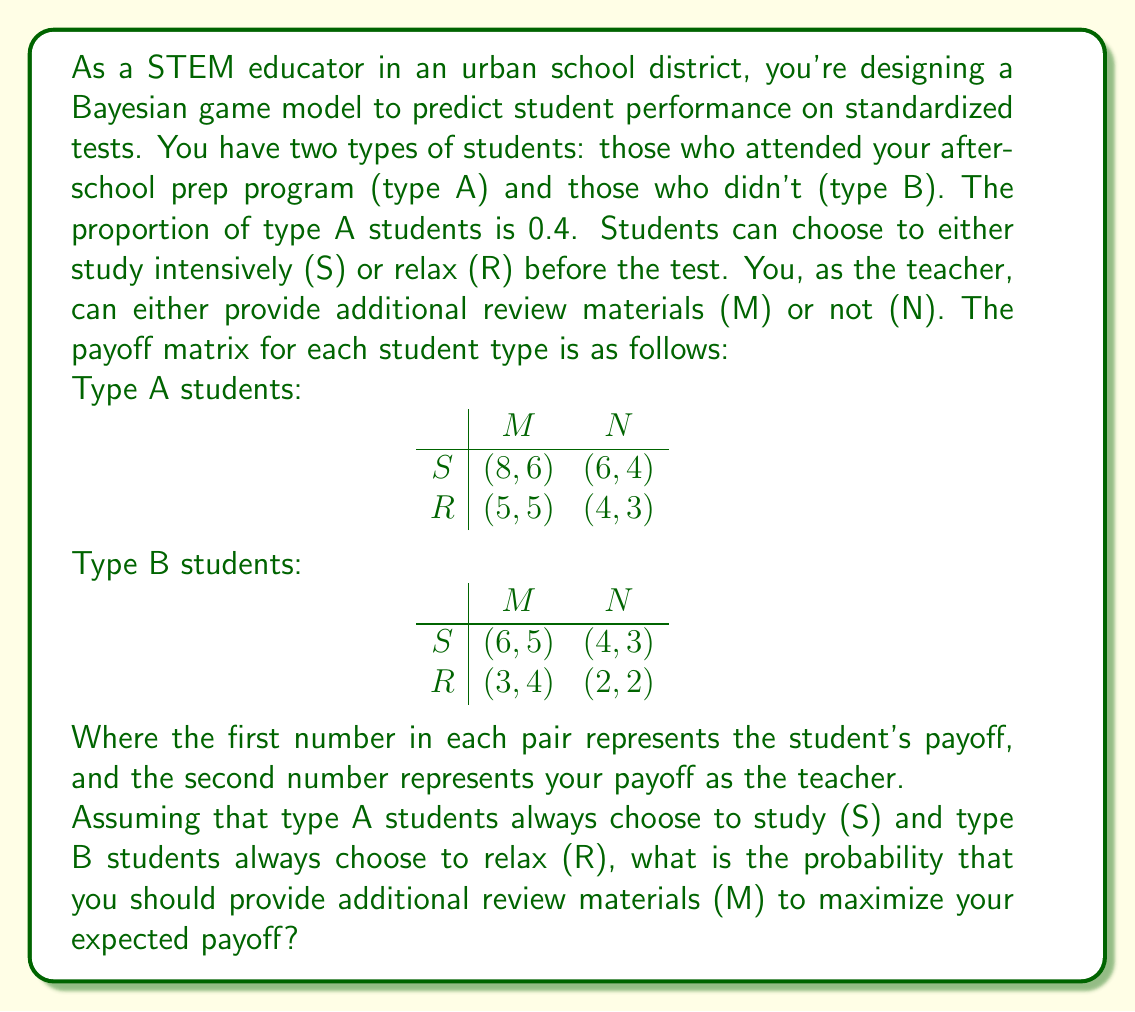Teach me how to tackle this problem. To solve this Bayesian game problem, we need to calculate the expected payoff for the teacher when choosing strategy M versus strategy N, given the probabilities of student types and their strategies.

1. Let's define our probabilities:
   $P(A) = 0.4$ (probability of type A student)
   $P(B) = 1 - P(A) = 0.6$ (probability of type B student)

2. Expected payoff for choosing strategy M:
   $E(M) = P(A) \cdot \text{Payoff}(A,S,M) + P(B) \cdot \text{Payoff}(B,R,M)$
   $E(M) = 0.4 \cdot 6 + 0.6 \cdot 4 = 2.4 + 2.4 = 4.8$

3. Expected payoff for choosing strategy N:
   $E(N) = P(A) \cdot \text{Payoff}(A,S,N) + P(B) \cdot \text{Payoff}(B,R,N)$
   $E(N) = 0.4 \cdot 4 + 0.6 \cdot 2 = 1.6 + 1.2 = 2.8$

4. To maximize expected payoff, we compare E(M) and E(N):
   $E(M) > E(N)$, so the teacher should choose strategy M.

5. To find the probability of choosing M, we can use the concept of mixed strategies. Let p be the probability of choosing M:

   $pE(M) + (1-p)E(N) = pE(M) + (1-p)E(M)$
   $p(4.8) + (1-p)(2.8) = p(4.8) + (1-p)(4.8)$
   $4.8p + 2.8 - 2.8p = 4.8$
   $2p = 2$
   $p = 1$

Therefore, the probability of choosing strategy M to maximize expected payoff is 1, or 100%.
Answer: The probability that you should provide additional review materials (M) to maximize your expected payoff is 1 (or 100%). 